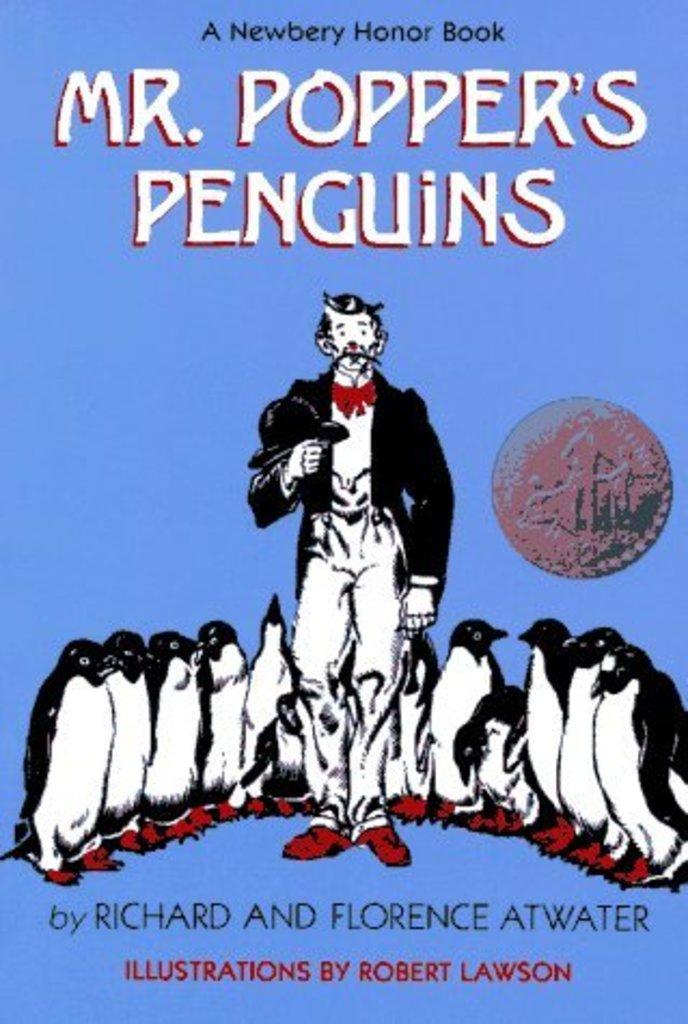Who is the author of mr. popper's penguins?
Give a very brief answer. Richard and florence atwater. Who drew the illustrations?
Keep it short and to the point. Robert lawson. 